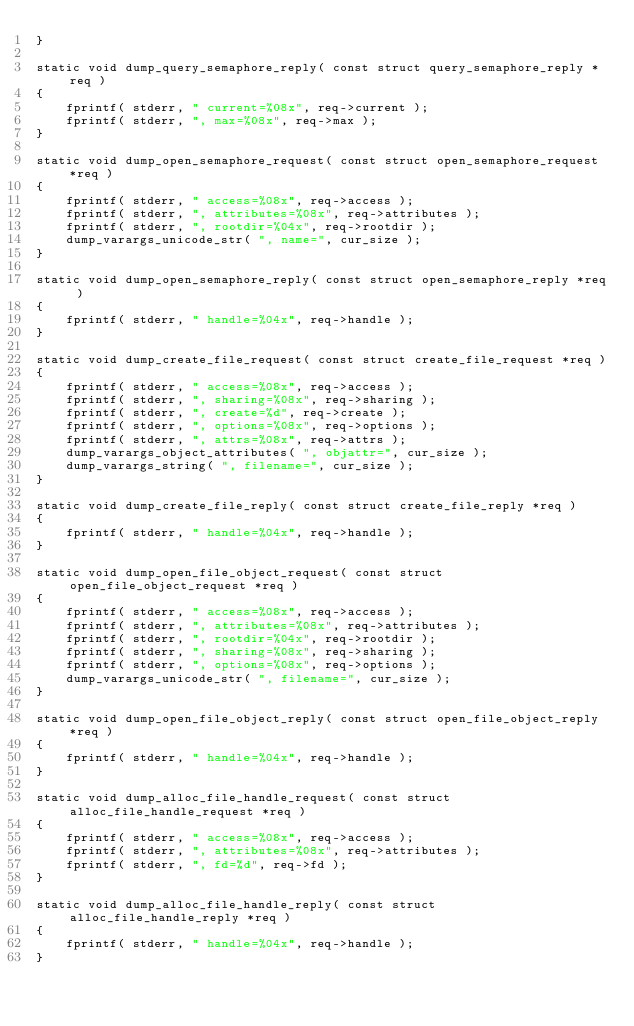<code> <loc_0><loc_0><loc_500><loc_500><_C_>}

static void dump_query_semaphore_reply( const struct query_semaphore_reply *req )
{
    fprintf( stderr, " current=%08x", req->current );
    fprintf( stderr, ", max=%08x", req->max );
}

static void dump_open_semaphore_request( const struct open_semaphore_request *req )
{
    fprintf( stderr, " access=%08x", req->access );
    fprintf( stderr, ", attributes=%08x", req->attributes );
    fprintf( stderr, ", rootdir=%04x", req->rootdir );
    dump_varargs_unicode_str( ", name=", cur_size );
}

static void dump_open_semaphore_reply( const struct open_semaphore_reply *req )
{
    fprintf( stderr, " handle=%04x", req->handle );
}

static void dump_create_file_request( const struct create_file_request *req )
{
    fprintf( stderr, " access=%08x", req->access );
    fprintf( stderr, ", sharing=%08x", req->sharing );
    fprintf( stderr, ", create=%d", req->create );
    fprintf( stderr, ", options=%08x", req->options );
    fprintf( stderr, ", attrs=%08x", req->attrs );
    dump_varargs_object_attributes( ", objattr=", cur_size );
    dump_varargs_string( ", filename=", cur_size );
}

static void dump_create_file_reply( const struct create_file_reply *req )
{
    fprintf( stderr, " handle=%04x", req->handle );
}

static void dump_open_file_object_request( const struct open_file_object_request *req )
{
    fprintf( stderr, " access=%08x", req->access );
    fprintf( stderr, ", attributes=%08x", req->attributes );
    fprintf( stderr, ", rootdir=%04x", req->rootdir );
    fprintf( stderr, ", sharing=%08x", req->sharing );
    fprintf( stderr, ", options=%08x", req->options );
    dump_varargs_unicode_str( ", filename=", cur_size );
}

static void dump_open_file_object_reply( const struct open_file_object_reply *req )
{
    fprintf( stderr, " handle=%04x", req->handle );
}

static void dump_alloc_file_handle_request( const struct alloc_file_handle_request *req )
{
    fprintf( stderr, " access=%08x", req->access );
    fprintf( stderr, ", attributes=%08x", req->attributes );
    fprintf( stderr, ", fd=%d", req->fd );
}

static void dump_alloc_file_handle_reply( const struct alloc_file_handle_reply *req )
{
    fprintf( stderr, " handle=%04x", req->handle );
}
</code> 